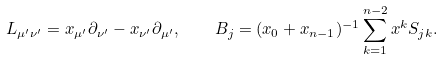<formula> <loc_0><loc_0><loc_500><loc_500>L _ { \mu ^ { \prime } \nu ^ { \prime } } = x _ { \mu ^ { \prime } } \partial _ { \nu ^ { \prime } } - x _ { \nu ^ { \prime } } \partial _ { \mu ^ { \prime } } , \quad B _ { j } = ( x _ { 0 } + x _ { n - 1 } ) ^ { - 1 } \sum ^ { n - 2 } _ { k = 1 } x ^ { k } S _ { j k } .</formula> 